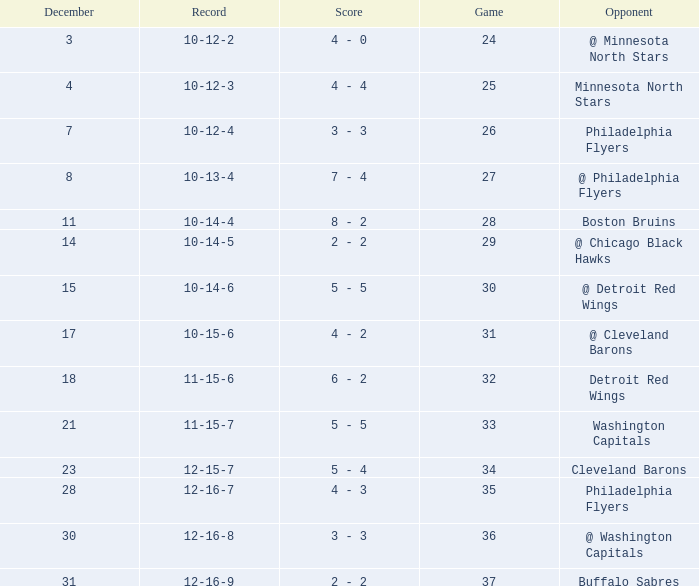What is the lowest December, when Score is "4 - 4"? 4.0. 